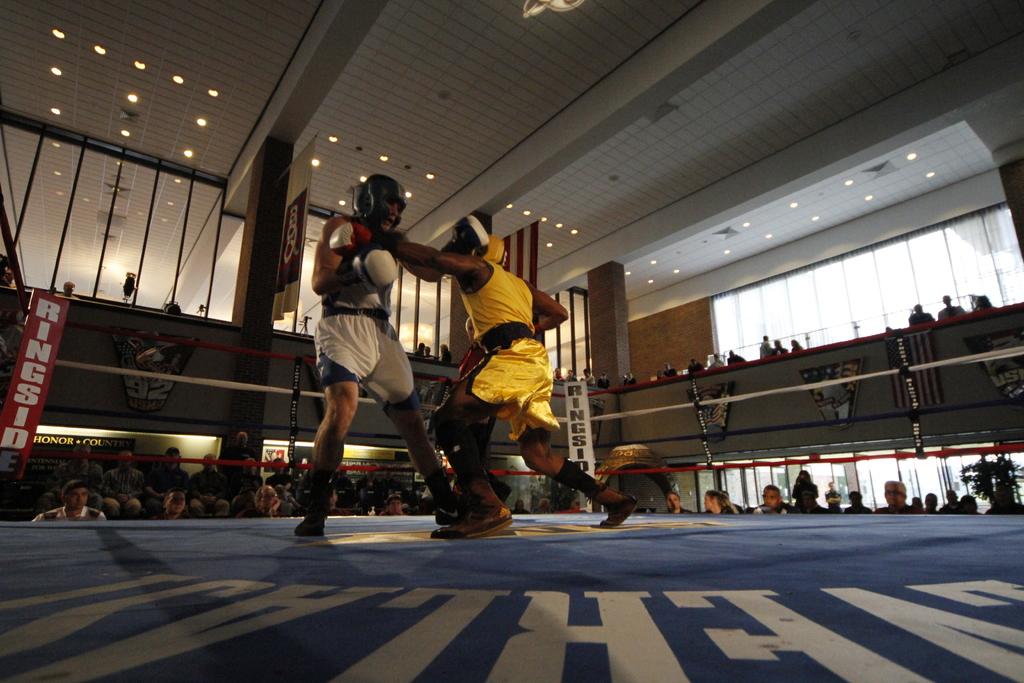What does it say on the corners of the ring?
Your answer should be compact. Ringside. 